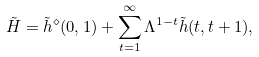Convert formula to latex. <formula><loc_0><loc_0><loc_500><loc_500>\tilde { H } = \tilde { h } ^ { \diamond } ( 0 , 1 ) + \sum _ { t = 1 } ^ { \infty } \Lambda ^ { 1 - t } \tilde { h } ( t , t + 1 ) ,</formula> 